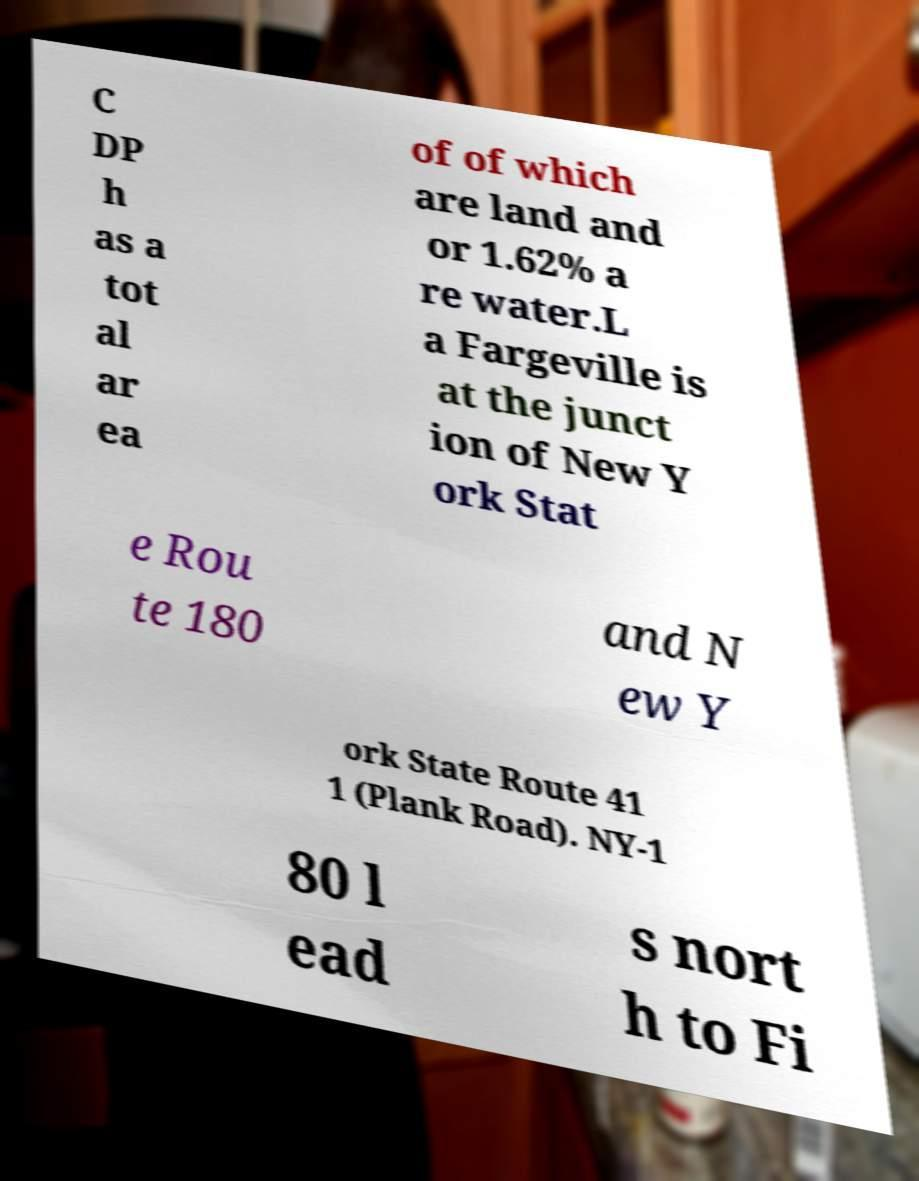Could you extract and type out the text from this image? C DP h as a tot al ar ea of of which are land and or 1.62% a re water.L a Fargeville is at the junct ion of New Y ork Stat e Rou te 180 and N ew Y ork State Route 41 1 (Plank Road). NY-1 80 l ead s nort h to Fi 